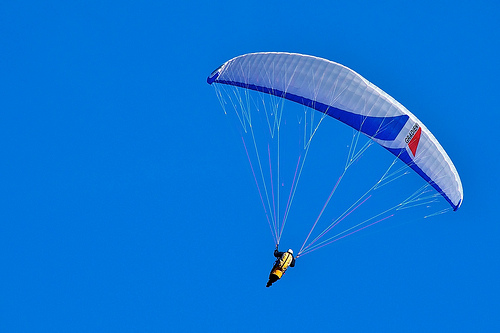Imagine you are living in a world where people communicate through colors instead of words. Describe what conversation might be happening in this picture. In a world where colors convey messages, the vibrant yellow of the person's vest might signify joy, energy, and readiness for adventure. The blue of the sky could represent calmness, freedom, and vast possibilities. Together, these colors communicate a dialogue of exhilaration and peace, with the person signaling their thrill of soaring through the expansive skies, embraced by the serene, boundless blue above them. Craft a fictional yet realistic scenario the person in the image could be experiencing. Provide a short and a long version. Short Scenario: The person in the image is an experienced paraglider instructor giving a demonstration to a group of eager students. They showcase various maneuvers and safety techniques, ensuring their students feel confident and excited for their upcoming solo flights. What's the longer version of the scenario? Long Scenario: Meet Jordan, a seasoned paraglider with years of experience under their belt. On this bright, cloudless day, Jordan is overseeing a special training session at a renowned paragliding course. The group consists of enthusiastic newcomers, each excited yet slightly nervous about taking to the skies for the first time.

Jordan begins with a comprehensive briefing, emphasizing the importance of safety procedures and demonstrating how to correctly handle the equipment. With a blend of humor and professionalism, they manage to ease the students' anxieties, making the learning process enjoyable and engaging.

As the session progresses, Jordan takes to the air to perform a series of advanced maneuvers. Skillfully gliding through the air, they execute smooth turns, gentle descents, and even a few thrilling acrobatics. The students watch in awe, inspired by Jordan's grace and control. After landing, Jordan spends time with each student, giving personalized tips and encouragement.

By the end of the day, the students feel more confident and ready to experience paragliding themselves. Jordan's expertise and approachable demeanor not only equip them with the necessary skills but also instill a deep appreciation for the beauty and excitement of flying. As the sun sets, the group shares stories and laughter, each one looking forward to their own airborne adventures, knowing they have a skilled mentor to guide them. 